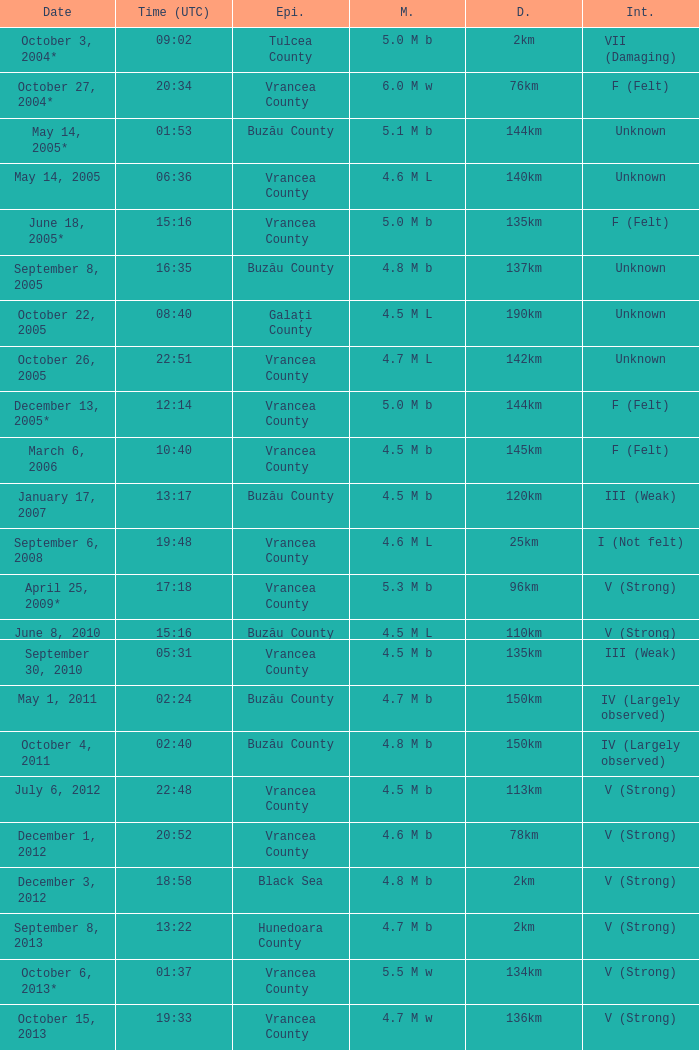Where was the epicenter of the quake on December 1, 2012? Vrancea County. Parse the full table. {'header': ['Date', 'Time (UTC)', 'Epi.', 'M.', 'D.', 'Int.'], 'rows': [['October 3, 2004*', '09:02', 'Tulcea County', '5.0 M b', '2km', 'VII (Damaging)'], ['October 27, 2004*', '20:34', 'Vrancea County', '6.0 M w', '76km', 'F (Felt)'], ['May 14, 2005*', '01:53', 'Buzău County', '5.1 M b', '144km', 'Unknown'], ['May 14, 2005', '06:36', 'Vrancea County', '4.6 M L', '140km', 'Unknown'], ['June 18, 2005*', '15:16', 'Vrancea County', '5.0 M b', '135km', 'F (Felt)'], ['September 8, 2005', '16:35', 'Buzău County', '4.8 M b', '137km', 'Unknown'], ['October 22, 2005', '08:40', 'Galați County', '4.5 M L', '190km', 'Unknown'], ['October 26, 2005', '22:51', 'Vrancea County', '4.7 M L', '142km', 'Unknown'], ['December 13, 2005*', '12:14', 'Vrancea County', '5.0 M b', '144km', 'F (Felt)'], ['March 6, 2006', '10:40', 'Vrancea County', '4.5 M b', '145km', 'F (Felt)'], ['January 17, 2007', '13:17', 'Buzău County', '4.5 M b', '120km', 'III (Weak)'], ['September 6, 2008', '19:48', 'Vrancea County', '4.6 M L', '25km', 'I (Not felt)'], ['April 25, 2009*', '17:18', 'Vrancea County', '5.3 M b', '96km', 'V (Strong)'], ['June 8, 2010', '15:16', 'Buzău County', '4.5 M L', '110km', 'V (Strong)'], ['September 30, 2010', '05:31', 'Vrancea County', '4.5 M b', '135km', 'III (Weak)'], ['May 1, 2011', '02:24', 'Buzău County', '4.7 M b', '150km', 'IV (Largely observed)'], ['October 4, 2011', '02:40', 'Buzău County', '4.8 M b', '150km', 'IV (Largely observed)'], ['July 6, 2012', '22:48', 'Vrancea County', '4.5 M b', '113km', 'V (Strong)'], ['December 1, 2012', '20:52', 'Vrancea County', '4.6 M b', '78km', 'V (Strong)'], ['December 3, 2012', '18:58', 'Black Sea', '4.8 M b', '2km', 'V (Strong)'], ['September 8, 2013', '13:22', 'Hunedoara County', '4.7 M b', '2km', 'V (Strong)'], ['October 6, 2013*', '01:37', 'Vrancea County', '5.5 M w', '134km', 'V (Strong)'], ['October 15, 2013', '19:33', 'Vrancea County', '4.7 M w', '136km', 'V (Strong)']]} 